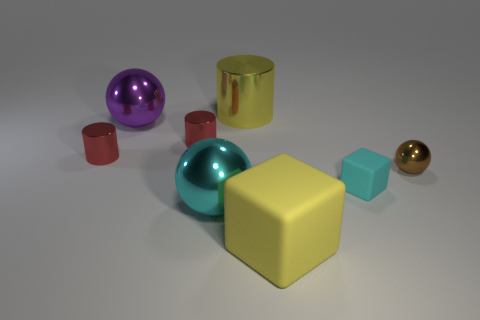Add 2 cyan cubes. How many objects exist? 10 Subtract all blocks. How many objects are left? 6 Add 7 small cyan matte cubes. How many small cyan matte cubes are left? 8 Add 5 small green metallic cubes. How many small green metallic cubes exist? 5 Subtract 0 gray blocks. How many objects are left? 8 Subtract all big yellow cylinders. Subtract all big yellow matte blocks. How many objects are left? 6 